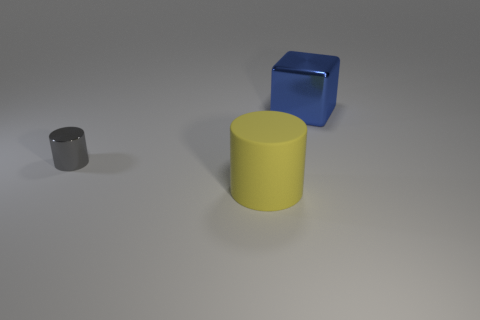Is there any indication of human activity in the image? There are no direct indications of human activity such as fingerprints, marks, or other items. The image is limited to a few simple objects placed on a flat surface. 